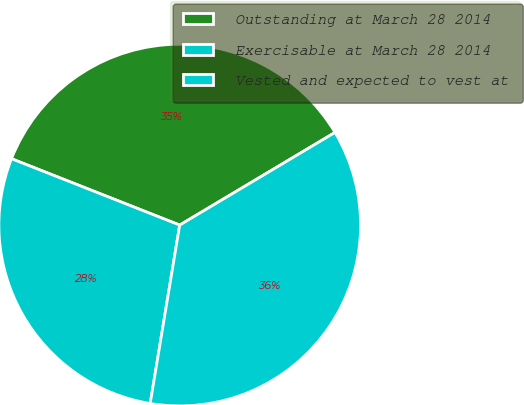Convert chart to OTSL. <chart><loc_0><loc_0><loc_500><loc_500><pie_chart><fcel>Outstanding at March 28 2014<fcel>Exercisable at March 28 2014<fcel>Vested and expected to vest at<nl><fcel>35.46%<fcel>28.37%<fcel>36.17%<nl></chart> 